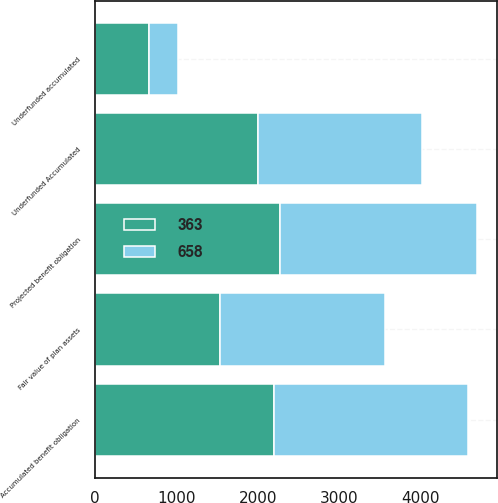<chart> <loc_0><loc_0><loc_500><loc_500><stacked_bar_chart><ecel><fcel>Underfunded Accumulated<fcel>Projected benefit obligation<fcel>Accumulated benefit obligation<fcel>Fair value of plan assets<fcel>Underfunded accumulated<nl><fcel>658<fcel>2009<fcel>2431<fcel>2389<fcel>2026<fcel>363<nl><fcel>363<fcel>2008<fcel>2272<fcel>2201<fcel>1543<fcel>658<nl></chart> 